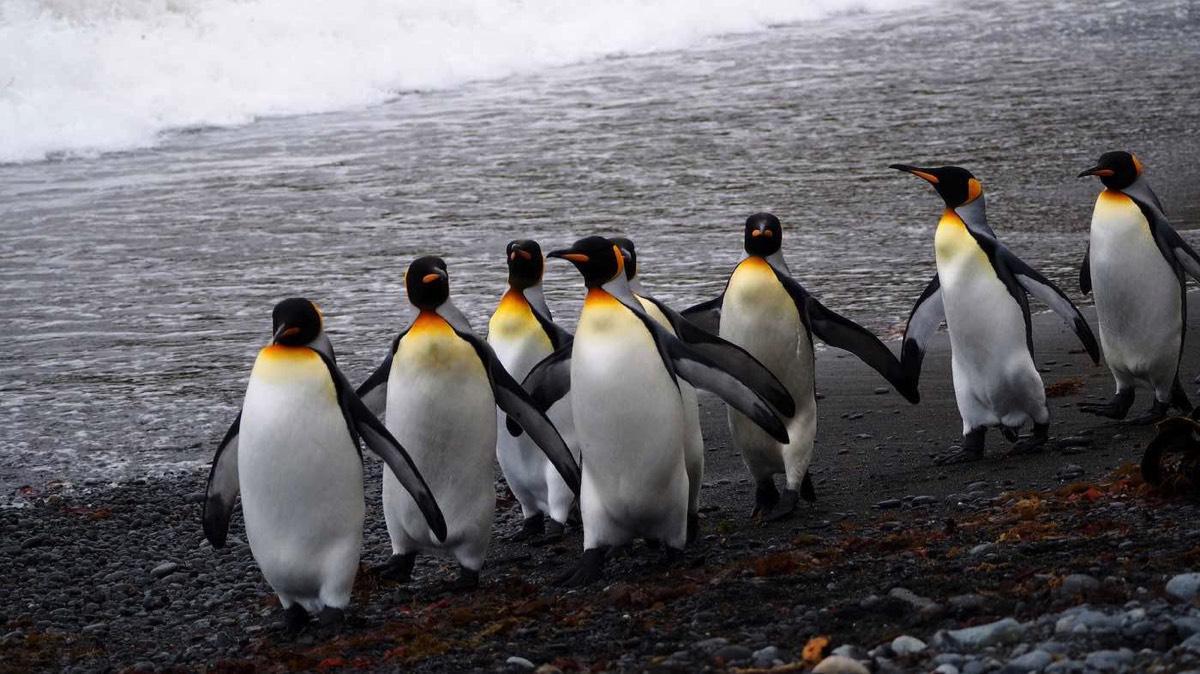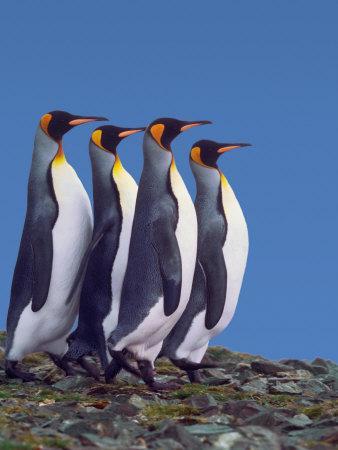The first image is the image on the left, the second image is the image on the right. Considering the images on both sides, is "There are no more than five penguins" valid? Answer yes or no. No. 